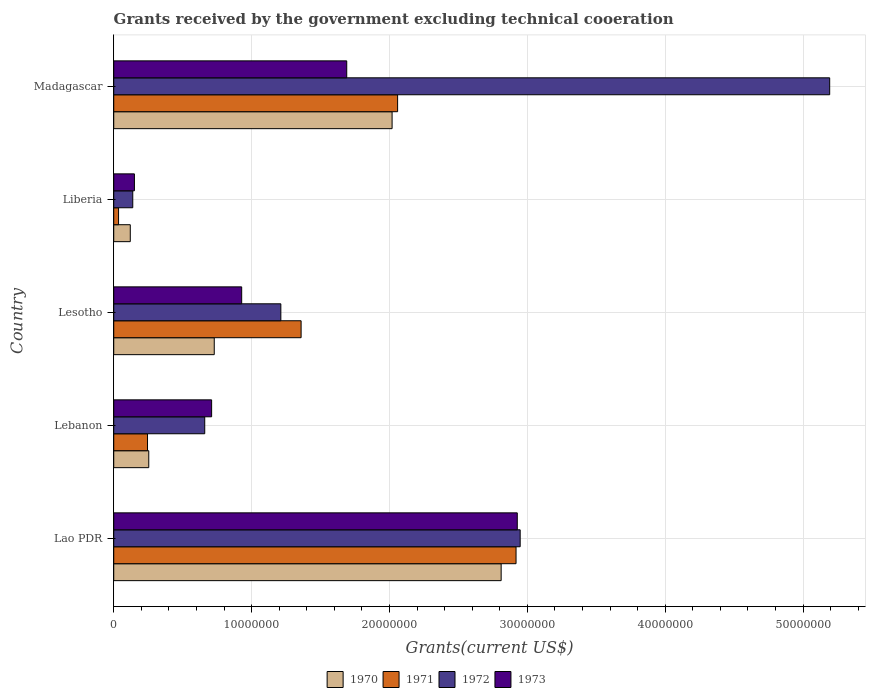Are the number of bars per tick equal to the number of legend labels?
Keep it short and to the point. Yes. Are the number of bars on each tick of the Y-axis equal?
Give a very brief answer. Yes. How many bars are there on the 1st tick from the top?
Provide a short and direct response. 4. How many bars are there on the 1st tick from the bottom?
Your answer should be very brief. 4. What is the label of the 2nd group of bars from the top?
Offer a very short reply. Liberia. In how many cases, is the number of bars for a given country not equal to the number of legend labels?
Ensure brevity in your answer.  0. What is the total grants received by the government in 1973 in Liberia?
Your answer should be very brief. 1.50e+06. Across all countries, what is the maximum total grants received by the government in 1973?
Your answer should be very brief. 2.93e+07. Across all countries, what is the minimum total grants received by the government in 1971?
Your answer should be very brief. 3.50e+05. In which country was the total grants received by the government in 1972 maximum?
Provide a short and direct response. Madagascar. In which country was the total grants received by the government in 1971 minimum?
Provide a succinct answer. Liberia. What is the total total grants received by the government in 1972 in the graph?
Offer a very short reply. 1.02e+08. What is the difference between the total grants received by the government in 1973 in Lesotho and that in Liberia?
Keep it short and to the point. 7.78e+06. What is the difference between the total grants received by the government in 1971 in Lao PDR and the total grants received by the government in 1972 in Lebanon?
Make the answer very short. 2.26e+07. What is the average total grants received by the government in 1973 per country?
Offer a terse response. 1.28e+07. What is the difference between the total grants received by the government in 1971 and total grants received by the government in 1970 in Liberia?
Keep it short and to the point. -8.50e+05. What is the ratio of the total grants received by the government in 1971 in Lao PDR to that in Lebanon?
Give a very brief answer. 11.91. What is the difference between the highest and the second highest total grants received by the government in 1973?
Give a very brief answer. 1.24e+07. What is the difference between the highest and the lowest total grants received by the government in 1971?
Your response must be concise. 2.88e+07. In how many countries, is the total grants received by the government in 1973 greater than the average total grants received by the government in 1973 taken over all countries?
Make the answer very short. 2. Is the sum of the total grants received by the government in 1973 in Lesotho and Madagascar greater than the maximum total grants received by the government in 1972 across all countries?
Keep it short and to the point. No. What does the 2nd bar from the top in Liberia represents?
Ensure brevity in your answer.  1972. What does the 4th bar from the bottom in Liberia represents?
Keep it short and to the point. 1973. How many countries are there in the graph?
Provide a short and direct response. 5. Are the values on the major ticks of X-axis written in scientific E-notation?
Your answer should be compact. No. Does the graph contain grids?
Keep it short and to the point. Yes. What is the title of the graph?
Keep it short and to the point. Grants received by the government excluding technical cooeration. Does "1981" appear as one of the legend labels in the graph?
Your answer should be very brief. No. What is the label or title of the X-axis?
Provide a short and direct response. Grants(current US$). What is the label or title of the Y-axis?
Keep it short and to the point. Country. What is the Grants(current US$) of 1970 in Lao PDR?
Provide a succinct answer. 2.81e+07. What is the Grants(current US$) in 1971 in Lao PDR?
Make the answer very short. 2.92e+07. What is the Grants(current US$) of 1972 in Lao PDR?
Give a very brief answer. 2.95e+07. What is the Grants(current US$) of 1973 in Lao PDR?
Your answer should be very brief. 2.93e+07. What is the Grants(current US$) of 1970 in Lebanon?
Your answer should be compact. 2.54e+06. What is the Grants(current US$) in 1971 in Lebanon?
Offer a terse response. 2.45e+06. What is the Grants(current US$) in 1972 in Lebanon?
Provide a succinct answer. 6.60e+06. What is the Grants(current US$) of 1973 in Lebanon?
Your response must be concise. 7.10e+06. What is the Grants(current US$) in 1970 in Lesotho?
Ensure brevity in your answer.  7.29e+06. What is the Grants(current US$) in 1971 in Lesotho?
Ensure brevity in your answer.  1.36e+07. What is the Grants(current US$) of 1972 in Lesotho?
Ensure brevity in your answer.  1.21e+07. What is the Grants(current US$) in 1973 in Lesotho?
Give a very brief answer. 9.28e+06. What is the Grants(current US$) in 1970 in Liberia?
Your answer should be compact. 1.20e+06. What is the Grants(current US$) of 1972 in Liberia?
Give a very brief answer. 1.38e+06. What is the Grants(current US$) of 1973 in Liberia?
Make the answer very short. 1.50e+06. What is the Grants(current US$) in 1970 in Madagascar?
Ensure brevity in your answer.  2.02e+07. What is the Grants(current US$) of 1971 in Madagascar?
Provide a short and direct response. 2.06e+07. What is the Grants(current US$) in 1972 in Madagascar?
Keep it short and to the point. 5.19e+07. What is the Grants(current US$) in 1973 in Madagascar?
Offer a very short reply. 1.69e+07. Across all countries, what is the maximum Grants(current US$) in 1970?
Offer a terse response. 2.81e+07. Across all countries, what is the maximum Grants(current US$) of 1971?
Provide a succinct answer. 2.92e+07. Across all countries, what is the maximum Grants(current US$) in 1972?
Ensure brevity in your answer.  5.19e+07. Across all countries, what is the maximum Grants(current US$) in 1973?
Offer a very short reply. 2.93e+07. Across all countries, what is the minimum Grants(current US$) in 1970?
Make the answer very short. 1.20e+06. Across all countries, what is the minimum Grants(current US$) in 1971?
Offer a very short reply. 3.50e+05. Across all countries, what is the minimum Grants(current US$) of 1972?
Your answer should be very brief. 1.38e+06. Across all countries, what is the minimum Grants(current US$) in 1973?
Offer a very short reply. 1.50e+06. What is the total Grants(current US$) of 1970 in the graph?
Ensure brevity in your answer.  5.93e+07. What is the total Grants(current US$) of 1971 in the graph?
Offer a very short reply. 6.62e+07. What is the total Grants(current US$) in 1972 in the graph?
Your answer should be very brief. 1.02e+08. What is the total Grants(current US$) of 1973 in the graph?
Your response must be concise. 6.40e+07. What is the difference between the Grants(current US$) of 1970 in Lao PDR and that in Lebanon?
Provide a short and direct response. 2.56e+07. What is the difference between the Grants(current US$) in 1971 in Lao PDR and that in Lebanon?
Offer a terse response. 2.67e+07. What is the difference between the Grants(current US$) of 1972 in Lao PDR and that in Lebanon?
Keep it short and to the point. 2.29e+07. What is the difference between the Grants(current US$) in 1973 in Lao PDR and that in Lebanon?
Your answer should be compact. 2.22e+07. What is the difference between the Grants(current US$) of 1970 in Lao PDR and that in Lesotho?
Provide a succinct answer. 2.08e+07. What is the difference between the Grants(current US$) of 1971 in Lao PDR and that in Lesotho?
Provide a succinct answer. 1.56e+07. What is the difference between the Grants(current US$) in 1972 in Lao PDR and that in Lesotho?
Your response must be concise. 1.74e+07. What is the difference between the Grants(current US$) in 1973 in Lao PDR and that in Lesotho?
Your answer should be very brief. 2.00e+07. What is the difference between the Grants(current US$) of 1970 in Lao PDR and that in Liberia?
Make the answer very short. 2.69e+07. What is the difference between the Grants(current US$) of 1971 in Lao PDR and that in Liberia?
Ensure brevity in your answer.  2.88e+07. What is the difference between the Grants(current US$) of 1972 in Lao PDR and that in Liberia?
Your response must be concise. 2.81e+07. What is the difference between the Grants(current US$) of 1973 in Lao PDR and that in Liberia?
Keep it short and to the point. 2.78e+07. What is the difference between the Grants(current US$) of 1970 in Lao PDR and that in Madagascar?
Offer a terse response. 7.91e+06. What is the difference between the Grants(current US$) in 1971 in Lao PDR and that in Madagascar?
Your response must be concise. 8.59e+06. What is the difference between the Grants(current US$) in 1972 in Lao PDR and that in Madagascar?
Give a very brief answer. -2.24e+07. What is the difference between the Grants(current US$) of 1973 in Lao PDR and that in Madagascar?
Give a very brief answer. 1.24e+07. What is the difference between the Grants(current US$) in 1970 in Lebanon and that in Lesotho?
Provide a short and direct response. -4.75e+06. What is the difference between the Grants(current US$) of 1971 in Lebanon and that in Lesotho?
Keep it short and to the point. -1.11e+07. What is the difference between the Grants(current US$) of 1972 in Lebanon and that in Lesotho?
Your answer should be compact. -5.52e+06. What is the difference between the Grants(current US$) of 1973 in Lebanon and that in Lesotho?
Provide a succinct answer. -2.18e+06. What is the difference between the Grants(current US$) of 1970 in Lebanon and that in Liberia?
Make the answer very short. 1.34e+06. What is the difference between the Grants(current US$) in 1971 in Lebanon and that in Liberia?
Ensure brevity in your answer.  2.10e+06. What is the difference between the Grants(current US$) in 1972 in Lebanon and that in Liberia?
Offer a very short reply. 5.22e+06. What is the difference between the Grants(current US$) of 1973 in Lebanon and that in Liberia?
Ensure brevity in your answer.  5.60e+06. What is the difference between the Grants(current US$) of 1970 in Lebanon and that in Madagascar?
Provide a succinct answer. -1.76e+07. What is the difference between the Grants(current US$) of 1971 in Lebanon and that in Madagascar?
Your response must be concise. -1.81e+07. What is the difference between the Grants(current US$) of 1972 in Lebanon and that in Madagascar?
Your response must be concise. -4.53e+07. What is the difference between the Grants(current US$) in 1973 in Lebanon and that in Madagascar?
Make the answer very short. -9.80e+06. What is the difference between the Grants(current US$) of 1970 in Lesotho and that in Liberia?
Keep it short and to the point. 6.09e+06. What is the difference between the Grants(current US$) in 1971 in Lesotho and that in Liberia?
Your answer should be very brief. 1.32e+07. What is the difference between the Grants(current US$) of 1972 in Lesotho and that in Liberia?
Offer a very short reply. 1.07e+07. What is the difference between the Grants(current US$) of 1973 in Lesotho and that in Liberia?
Make the answer very short. 7.78e+06. What is the difference between the Grants(current US$) in 1970 in Lesotho and that in Madagascar?
Provide a succinct answer. -1.29e+07. What is the difference between the Grants(current US$) of 1971 in Lesotho and that in Madagascar?
Ensure brevity in your answer.  -7.00e+06. What is the difference between the Grants(current US$) in 1972 in Lesotho and that in Madagascar?
Your answer should be compact. -3.98e+07. What is the difference between the Grants(current US$) in 1973 in Lesotho and that in Madagascar?
Offer a terse response. -7.62e+06. What is the difference between the Grants(current US$) of 1970 in Liberia and that in Madagascar?
Offer a terse response. -1.90e+07. What is the difference between the Grants(current US$) in 1971 in Liberia and that in Madagascar?
Give a very brief answer. -2.02e+07. What is the difference between the Grants(current US$) in 1972 in Liberia and that in Madagascar?
Give a very brief answer. -5.06e+07. What is the difference between the Grants(current US$) of 1973 in Liberia and that in Madagascar?
Give a very brief answer. -1.54e+07. What is the difference between the Grants(current US$) of 1970 in Lao PDR and the Grants(current US$) of 1971 in Lebanon?
Your answer should be very brief. 2.56e+07. What is the difference between the Grants(current US$) of 1970 in Lao PDR and the Grants(current US$) of 1972 in Lebanon?
Keep it short and to the point. 2.15e+07. What is the difference between the Grants(current US$) of 1970 in Lao PDR and the Grants(current US$) of 1973 in Lebanon?
Keep it short and to the point. 2.10e+07. What is the difference between the Grants(current US$) in 1971 in Lao PDR and the Grants(current US$) in 1972 in Lebanon?
Your response must be concise. 2.26e+07. What is the difference between the Grants(current US$) in 1971 in Lao PDR and the Grants(current US$) in 1973 in Lebanon?
Provide a succinct answer. 2.21e+07. What is the difference between the Grants(current US$) in 1972 in Lao PDR and the Grants(current US$) in 1973 in Lebanon?
Make the answer very short. 2.24e+07. What is the difference between the Grants(current US$) of 1970 in Lao PDR and the Grants(current US$) of 1971 in Lesotho?
Offer a very short reply. 1.45e+07. What is the difference between the Grants(current US$) in 1970 in Lao PDR and the Grants(current US$) in 1972 in Lesotho?
Your response must be concise. 1.60e+07. What is the difference between the Grants(current US$) in 1970 in Lao PDR and the Grants(current US$) in 1973 in Lesotho?
Provide a short and direct response. 1.88e+07. What is the difference between the Grants(current US$) in 1971 in Lao PDR and the Grants(current US$) in 1972 in Lesotho?
Your response must be concise. 1.71e+07. What is the difference between the Grants(current US$) in 1971 in Lao PDR and the Grants(current US$) in 1973 in Lesotho?
Provide a succinct answer. 1.99e+07. What is the difference between the Grants(current US$) in 1972 in Lao PDR and the Grants(current US$) in 1973 in Lesotho?
Your answer should be compact. 2.02e+07. What is the difference between the Grants(current US$) in 1970 in Lao PDR and the Grants(current US$) in 1971 in Liberia?
Your response must be concise. 2.78e+07. What is the difference between the Grants(current US$) of 1970 in Lao PDR and the Grants(current US$) of 1972 in Liberia?
Provide a short and direct response. 2.67e+07. What is the difference between the Grants(current US$) in 1970 in Lao PDR and the Grants(current US$) in 1973 in Liberia?
Your response must be concise. 2.66e+07. What is the difference between the Grants(current US$) of 1971 in Lao PDR and the Grants(current US$) of 1972 in Liberia?
Provide a succinct answer. 2.78e+07. What is the difference between the Grants(current US$) in 1971 in Lao PDR and the Grants(current US$) in 1973 in Liberia?
Your answer should be very brief. 2.77e+07. What is the difference between the Grants(current US$) in 1972 in Lao PDR and the Grants(current US$) in 1973 in Liberia?
Provide a succinct answer. 2.80e+07. What is the difference between the Grants(current US$) in 1970 in Lao PDR and the Grants(current US$) in 1971 in Madagascar?
Ensure brevity in your answer.  7.51e+06. What is the difference between the Grants(current US$) of 1970 in Lao PDR and the Grants(current US$) of 1972 in Madagascar?
Your answer should be very brief. -2.38e+07. What is the difference between the Grants(current US$) of 1970 in Lao PDR and the Grants(current US$) of 1973 in Madagascar?
Give a very brief answer. 1.12e+07. What is the difference between the Grants(current US$) of 1971 in Lao PDR and the Grants(current US$) of 1972 in Madagascar?
Ensure brevity in your answer.  -2.28e+07. What is the difference between the Grants(current US$) in 1971 in Lao PDR and the Grants(current US$) in 1973 in Madagascar?
Provide a succinct answer. 1.23e+07. What is the difference between the Grants(current US$) in 1972 in Lao PDR and the Grants(current US$) in 1973 in Madagascar?
Your response must be concise. 1.26e+07. What is the difference between the Grants(current US$) in 1970 in Lebanon and the Grants(current US$) in 1971 in Lesotho?
Provide a succinct answer. -1.10e+07. What is the difference between the Grants(current US$) in 1970 in Lebanon and the Grants(current US$) in 1972 in Lesotho?
Your answer should be very brief. -9.58e+06. What is the difference between the Grants(current US$) in 1970 in Lebanon and the Grants(current US$) in 1973 in Lesotho?
Provide a short and direct response. -6.74e+06. What is the difference between the Grants(current US$) in 1971 in Lebanon and the Grants(current US$) in 1972 in Lesotho?
Ensure brevity in your answer.  -9.67e+06. What is the difference between the Grants(current US$) of 1971 in Lebanon and the Grants(current US$) of 1973 in Lesotho?
Ensure brevity in your answer.  -6.83e+06. What is the difference between the Grants(current US$) in 1972 in Lebanon and the Grants(current US$) in 1973 in Lesotho?
Make the answer very short. -2.68e+06. What is the difference between the Grants(current US$) of 1970 in Lebanon and the Grants(current US$) of 1971 in Liberia?
Keep it short and to the point. 2.19e+06. What is the difference between the Grants(current US$) in 1970 in Lebanon and the Grants(current US$) in 1972 in Liberia?
Your answer should be very brief. 1.16e+06. What is the difference between the Grants(current US$) in 1970 in Lebanon and the Grants(current US$) in 1973 in Liberia?
Ensure brevity in your answer.  1.04e+06. What is the difference between the Grants(current US$) of 1971 in Lebanon and the Grants(current US$) of 1972 in Liberia?
Your answer should be compact. 1.07e+06. What is the difference between the Grants(current US$) of 1971 in Lebanon and the Grants(current US$) of 1973 in Liberia?
Your response must be concise. 9.50e+05. What is the difference between the Grants(current US$) of 1972 in Lebanon and the Grants(current US$) of 1973 in Liberia?
Give a very brief answer. 5.10e+06. What is the difference between the Grants(current US$) in 1970 in Lebanon and the Grants(current US$) in 1971 in Madagascar?
Offer a very short reply. -1.80e+07. What is the difference between the Grants(current US$) of 1970 in Lebanon and the Grants(current US$) of 1972 in Madagascar?
Provide a short and direct response. -4.94e+07. What is the difference between the Grants(current US$) in 1970 in Lebanon and the Grants(current US$) in 1973 in Madagascar?
Offer a very short reply. -1.44e+07. What is the difference between the Grants(current US$) of 1971 in Lebanon and the Grants(current US$) of 1972 in Madagascar?
Offer a terse response. -4.95e+07. What is the difference between the Grants(current US$) of 1971 in Lebanon and the Grants(current US$) of 1973 in Madagascar?
Your answer should be very brief. -1.44e+07. What is the difference between the Grants(current US$) in 1972 in Lebanon and the Grants(current US$) in 1973 in Madagascar?
Offer a terse response. -1.03e+07. What is the difference between the Grants(current US$) of 1970 in Lesotho and the Grants(current US$) of 1971 in Liberia?
Keep it short and to the point. 6.94e+06. What is the difference between the Grants(current US$) in 1970 in Lesotho and the Grants(current US$) in 1972 in Liberia?
Ensure brevity in your answer.  5.91e+06. What is the difference between the Grants(current US$) in 1970 in Lesotho and the Grants(current US$) in 1973 in Liberia?
Your answer should be compact. 5.79e+06. What is the difference between the Grants(current US$) of 1971 in Lesotho and the Grants(current US$) of 1972 in Liberia?
Your answer should be very brief. 1.22e+07. What is the difference between the Grants(current US$) in 1971 in Lesotho and the Grants(current US$) in 1973 in Liberia?
Offer a terse response. 1.21e+07. What is the difference between the Grants(current US$) in 1972 in Lesotho and the Grants(current US$) in 1973 in Liberia?
Keep it short and to the point. 1.06e+07. What is the difference between the Grants(current US$) in 1970 in Lesotho and the Grants(current US$) in 1971 in Madagascar?
Provide a succinct answer. -1.33e+07. What is the difference between the Grants(current US$) in 1970 in Lesotho and the Grants(current US$) in 1972 in Madagascar?
Provide a short and direct response. -4.46e+07. What is the difference between the Grants(current US$) of 1970 in Lesotho and the Grants(current US$) of 1973 in Madagascar?
Make the answer very short. -9.61e+06. What is the difference between the Grants(current US$) in 1971 in Lesotho and the Grants(current US$) in 1972 in Madagascar?
Offer a terse response. -3.83e+07. What is the difference between the Grants(current US$) of 1971 in Lesotho and the Grants(current US$) of 1973 in Madagascar?
Your answer should be very brief. -3.31e+06. What is the difference between the Grants(current US$) in 1972 in Lesotho and the Grants(current US$) in 1973 in Madagascar?
Ensure brevity in your answer.  -4.78e+06. What is the difference between the Grants(current US$) of 1970 in Liberia and the Grants(current US$) of 1971 in Madagascar?
Give a very brief answer. -1.94e+07. What is the difference between the Grants(current US$) of 1970 in Liberia and the Grants(current US$) of 1972 in Madagascar?
Your answer should be compact. -5.07e+07. What is the difference between the Grants(current US$) in 1970 in Liberia and the Grants(current US$) in 1973 in Madagascar?
Provide a short and direct response. -1.57e+07. What is the difference between the Grants(current US$) of 1971 in Liberia and the Grants(current US$) of 1972 in Madagascar?
Keep it short and to the point. -5.16e+07. What is the difference between the Grants(current US$) of 1971 in Liberia and the Grants(current US$) of 1973 in Madagascar?
Make the answer very short. -1.66e+07. What is the difference between the Grants(current US$) in 1972 in Liberia and the Grants(current US$) in 1973 in Madagascar?
Keep it short and to the point. -1.55e+07. What is the average Grants(current US$) of 1970 per country?
Give a very brief answer. 1.19e+07. What is the average Grants(current US$) of 1971 per country?
Make the answer very short. 1.32e+07. What is the average Grants(current US$) of 1972 per country?
Give a very brief answer. 2.03e+07. What is the average Grants(current US$) in 1973 per country?
Provide a short and direct response. 1.28e+07. What is the difference between the Grants(current US$) of 1970 and Grants(current US$) of 1971 in Lao PDR?
Provide a succinct answer. -1.08e+06. What is the difference between the Grants(current US$) in 1970 and Grants(current US$) in 1972 in Lao PDR?
Give a very brief answer. -1.38e+06. What is the difference between the Grants(current US$) in 1970 and Grants(current US$) in 1973 in Lao PDR?
Provide a short and direct response. -1.17e+06. What is the difference between the Grants(current US$) in 1971 and Grants(current US$) in 1972 in Lao PDR?
Your response must be concise. -3.00e+05. What is the difference between the Grants(current US$) of 1972 and Grants(current US$) of 1973 in Lao PDR?
Your answer should be very brief. 2.10e+05. What is the difference between the Grants(current US$) in 1970 and Grants(current US$) in 1971 in Lebanon?
Your answer should be compact. 9.00e+04. What is the difference between the Grants(current US$) of 1970 and Grants(current US$) of 1972 in Lebanon?
Offer a very short reply. -4.06e+06. What is the difference between the Grants(current US$) of 1970 and Grants(current US$) of 1973 in Lebanon?
Offer a terse response. -4.56e+06. What is the difference between the Grants(current US$) in 1971 and Grants(current US$) in 1972 in Lebanon?
Offer a terse response. -4.15e+06. What is the difference between the Grants(current US$) in 1971 and Grants(current US$) in 1973 in Lebanon?
Provide a succinct answer. -4.65e+06. What is the difference between the Grants(current US$) in 1972 and Grants(current US$) in 1973 in Lebanon?
Keep it short and to the point. -5.00e+05. What is the difference between the Grants(current US$) of 1970 and Grants(current US$) of 1971 in Lesotho?
Your response must be concise. -6.30e+06. What is the difference between the Grants(current US$) in 1970 and Grants(current US$) in 1972 in Lesotho?
Keep it short and to the point. -4.83e+06. What is the difference between the Grants(current US$) in 1970 and Grants(current US$) in 1973 in Lesotho?
Offer a very short reply. -1.99e+06. What is the difference between the Grants(current US$) of 1971 and Grants(current US$) of 1972 in Lesotho?
Your answer should be very brief. 1.47e+06. What is the difference between the Grants(current US$) in 1971 and Grants(current US$) in 1973 in Lesotho?
Give a very brief answer. 4.31e+06. What is the difference between the Grants(current US$) of 1972 and Grants(current US$) of 1973 in Lesotho?
Provide a short and direct response. 2.84e+06. What is the difference between the Grants(current US$) in 1970 and Grants(current US$) in 1971 in Liberia?
Provide a short and direct response. 8.50e+05. What is the difference between the Grants(current US$) in 1971 and Grants(current US$) in 1972 in Liberia?
Ensure brevity in your answer.  -1.03e+06. What is the difference between the Grants(current US$) in 1971 and Grants(current US$) in 1973 in Liberia?
Your answer should be very brief. -1.15e+06. What is the difference between the Grants(current US$) in 1970 and Grants(current US$) in 1971 in Madagascar?
Keep it short and to the point. -4.00e+05. What is the difference between the Grants(current US$) of 1970 and Grants(current US$) of 1972 in Madagascar?
Offer a very short reply. -3.17e+07. What is the difference between the Grants(current US$) in 1970 and Grants(current US$) in 1973 in Madagascar?
Make the answer very short. 3.29e+06. What is the difference between the Grants(current US$) of 1971 and Grants(current US$) of 1972 in Madagascar?
Ensure brevity in your answer.  -3.13e+07. What is the difference between the Grants(current US$) in 1971 and Grants(current US$) in 1973 in Madagascar?
Your answer should be compact. 3.69e+06. What is the difference between the Grants(current US$) of 1972 and Grants(current US$) of 1973 in Madagascar?
Offer a terse response. 3.50e+07. What is the ratio of the Grants(current US$) of 1970 in Lao PDR to that in Lebanon?
Make the answer very short. 11.06. What is the ratio of the Grants(current US$) of 1971 in Lao PDR to that in Lebanon?
Provide a short and direct response. 11.91. What is the ratio of the Grants(current US$) in 1972 in Lao PDR to that in Lebanon?
Provide a succinct answer. 4.47. What is the ratio of the Grants(current US$) of 1973 in Lao PDR to that in Lebanon?
Offer a terse response. 4.12. What is the ratio of the Grants(current US$) in 1970 in Lao PDR to that in Lesotho?
Provide a succinct answer. 3.85. What is the ratio of the Grants(current US$) of 1971 in Lao PDR to that in Lesotho?
Ensure brevity in your answer.  2.15. What is the ratio of the Grants(current US$) in 1972 in Lao PDR to that in Lesotho?
Offer a very short reply. 2.43. What is the ratio of the Grants(current US$) in 1973 in Lao PDR to that in Lesotho?
Make the answer very short. 3.15. What is the ratio of the Grants(current US$) of 1970 in Lao PDR to that in Liberia?
Your response must be concise. 23.42. What is the ratio of the Grants(current US$) in 1971 in Lao PDR to that in Liberia?
Keep it short and to the point. 83.37. What is the ratio of the Grants(current US$) of 1972 in Lao PDR to that in Liberia?
Give a very brief answer. 21.36. What is the ratio of the Grants(current US$) in 1973 in Lao PDR to that in Liberia?
Offer a very short reply. 19.51. What is the ratio of the Grants(current US$) of 1970 in Lao PDR to that in Madagascar?
Offer a very short reply. 1.39. What is the ratio of the Grants(current US$) of 1971 in Lao PDR to that in Madagascar?
Your answer should be compact. 1.42. What is the ratio of the Grants(current US$) in 1972 in Lao PDR to that in Madagascar?
Make the answer very short. 0.57. What is the ratio of the Grants(current US$) of 1973 in Lao PDR to that in Madagascar?
Provide a short and direct response. 1.73. What is the ratio of the Grants(current US$) in 1970 in Lebanon to that in Lesotho?
Your answer should be very brief. 0.35. What is the ratio of the Grants(current US$) of 1971 in Lebanon to that in Lesotho?
Provide a short and direct response. 0.18. What is the ratio of the Grants(current US$) of 1972 in Lebanon to that in Lesotho?
Make the answer very short. 0.54. What is the ratio of the Grants(current US$) in 1973 in Lebanon to that in Lesotho?
Offer a terse response. 0.77. What is the ratio of the Grants(current US$) in 1970 in Lebanon to that in Liberia?
Provide a succinct answer. 2.12. What is the ratio of the Grants(current US$) of 1971 in Lebanon to that in Liberia?
Offer a terse response. 7. What is the ratio of the Grants(current US$) in 1972 in Lebanon to that in Liberia?
Your answer should be compact. 4.78. What is the ratio of the Grants(current US$) in 1973 in Lebanon to that in Liberia?
Your answer should be compact. 4.73. What is the ratio of the Grants(current US$) in 1970 in Lebanon to that in Madagascar?
Make the answer very short. 0.13. What is the ratio of the Grants(current US$) of 1971 in Lebanon to that in Madagascar?
Offer a terse response. 0.12. What is the ratio of the Grants(current US$) of 1972 in Lebanon to that in Madagascar?
Your answer should be compact. 0.13. What is the ratio of the Grants(current US$) of 1973 in Lebanon to that in Madagascar?
Make the answer very short. 0.42. What is the ratio of the Grants(current US$) in 1970 in Lesotho to that in Liberia?
Make the answer very short. 6.08. What is the ratio of the Grants(current US$) in 1971 in Lesotho to that in Liberia?
Your response must be concise. 38.83. What is the ratio of the Grants(current US$) of 1972 in Lesotho to that in Liberia?
Your response must be concise. 8.78. What is the ratio of the Grants(current US$) in 1973 in Lesotho to that in Liberia?
Keep it short and to the point. 6.19. What is the ratio of the Grants(current US$) of 1970 in Lesotho to that in Madagascar?
Give a very brief answer. 0.36. What is the ratio of the Grants(current US$) of 1971 in Lesotho to that in Madagascar?
Make the answer very short. 0.66. What is the ratio of the Grants(current US$) of 1972 in Lesotho to that in Madagascar?
Ensure brevity in your answer.  0.23. What is the ratio of the Grants(current US$) of 1973 in Lesotho to that in Madagascar?
Offer a terse response. 0.55. What is the ratio of the Grants(current US$) of 1970 in Liberia to that in Madagascar?
Offer a terse response. 0.06. What is the ratio of the Grants(current US$) in 1971 in Liberia to that in Madagascar?
Your response must be concise. 0.02. What is the ratio of the Grants(current US$) in 1972 in Liberia to that in Madagascar?
Your answer should be compact. 0.03. What is the ratio of the Grants(current US$) of 1973 in Liberia to that in Madagascar?
Provide a succinct answer. 0.09. What is the difference between the highest and the second highest Grants(current US$) in 1970?
Keep it short and to the point. 7.91e+06. What is the difference between the highest and the second highest Grants(current US$) in 1971?
Provide a short and direct response. 8.59e+06. What is the difference between the highest and the second highest Grants(current US$) of 1972?
Provide a short and direct response. 2.24e+07. What is the difference between the highest and the second highest Grants(current US$) in 1973?
Ensure brevity in your answer.  1.24e+07. What is the difference between the highest and the lowest Grants(current US$) in 1970?
Provide a short and direct response. 2.69e+07. What is the difference between the highest and the lowest Grants(current US$) in 1971?
Offer a terse response. 2.88e+07. What is the difference between the highest and the lowest Grants(current US$) in 1972?
Your response must be concise. 5.06e+07. What is the difference between the highest and the lowest Grants(current US$) in 1973?
Make the answer very short. 2.78e+07. 